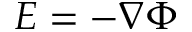Convert formula to latex. <formula><loc_0><loc_0><loc_500><loc_500>E = - \nabla \Phi</formula> 